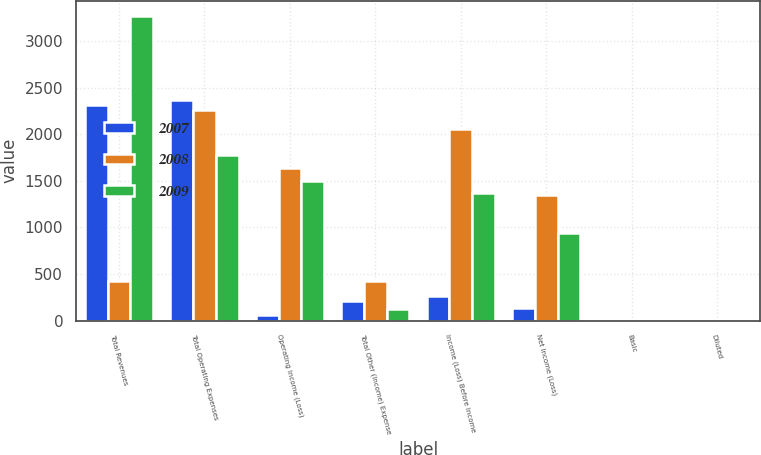<chart> <loc_0><loc_0><loc_500><loc_500><stacked_bar_chart><ecel><fcel>Total Revenues<fcel>Total Operating Expenses<fcel>Operating Income (Loss)<fcel>Total Other (Income) Expense<fcel>Income (Loss) Before Income<fcel>Net Income (Loss)<fcel>Basic<fcel>Diluted<nl><fcel>2007<fcel>2313<fcel>2371<fcel>58<fcel>206<fcel>264<fcel>131<fcel>0.75<fcel>0.75<nl><fcel>2008<fcel>426<fcel>2266<fcel>1635<fcel>426<fcel>2061<fcel>1350<fcel>7.83<fcel>7.58<nl><fcel>2009<fcel>3272<fcel>1777<fcel>1495<fcel>127<fcel>1368<fcel>944<fcel>5.52<fcel>5.45<nl></chart> 